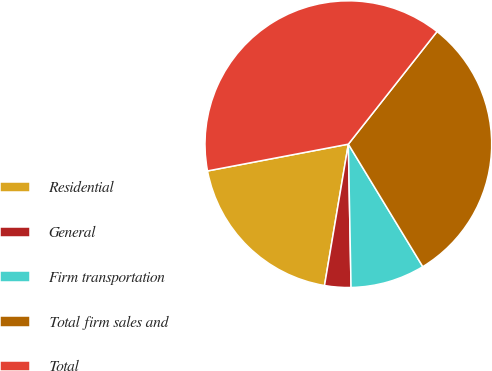Convert chart to OTSL. <chart><loc_0><loc_0><loc_500><loc_500><pie_chart><fcel>Residential<fcel>General<fcel>Firm transportation<fcel>Total firm sales and<fcel>Total<nl><fcel>19.35%<fcel>2.96%<fcel>8.39%<fcel>30.69%<fcel>38.61%<nl></chart> 